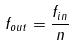Convert formula to latex. <formula><loc_0><loc_0><loc_500><loc_500>f _ { o u t } = \frac { f _ { i n } } { n }</formula> 